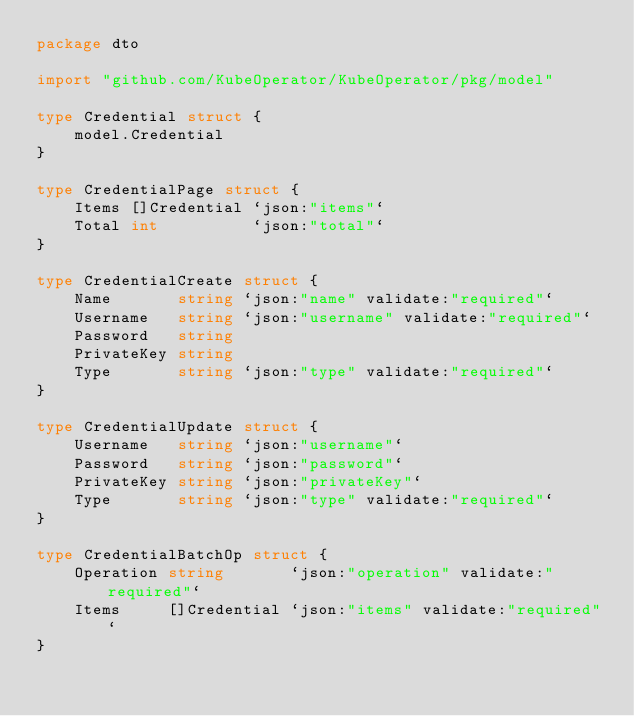<code> <loc_0><loc_0><loc_500><loc_500><_Go_>package dto

import "github.com/KubeOperator/KubeOperator/pkg/model"

type Credential struct {
	model.Credential
}

type CredentialPage struct {
	Items []Credential `json:"items"`
	Total int          `json:"total"`
}

type CredentialCreate struct {
	Name       string `json:"name" validate:"required"`
	Username   string `json:"username" validate:"required"`
	Password   string
	PrivateKey string
	Type       string `json:"type" validate:"required"`
}

type CredentialUpdate struct {
	Username   string `json:"username"`
	Password   string `json:"password"`
	PrivateKey string `json:"privateKey"`
	Type       string `json:"type" validate:"required"`
}

type CredentialBatchOp struct {
	Operation string       `json:"operation" validate:"required"`
	Items     []Credential `json:"items" validate:"required"`
}
</code> 